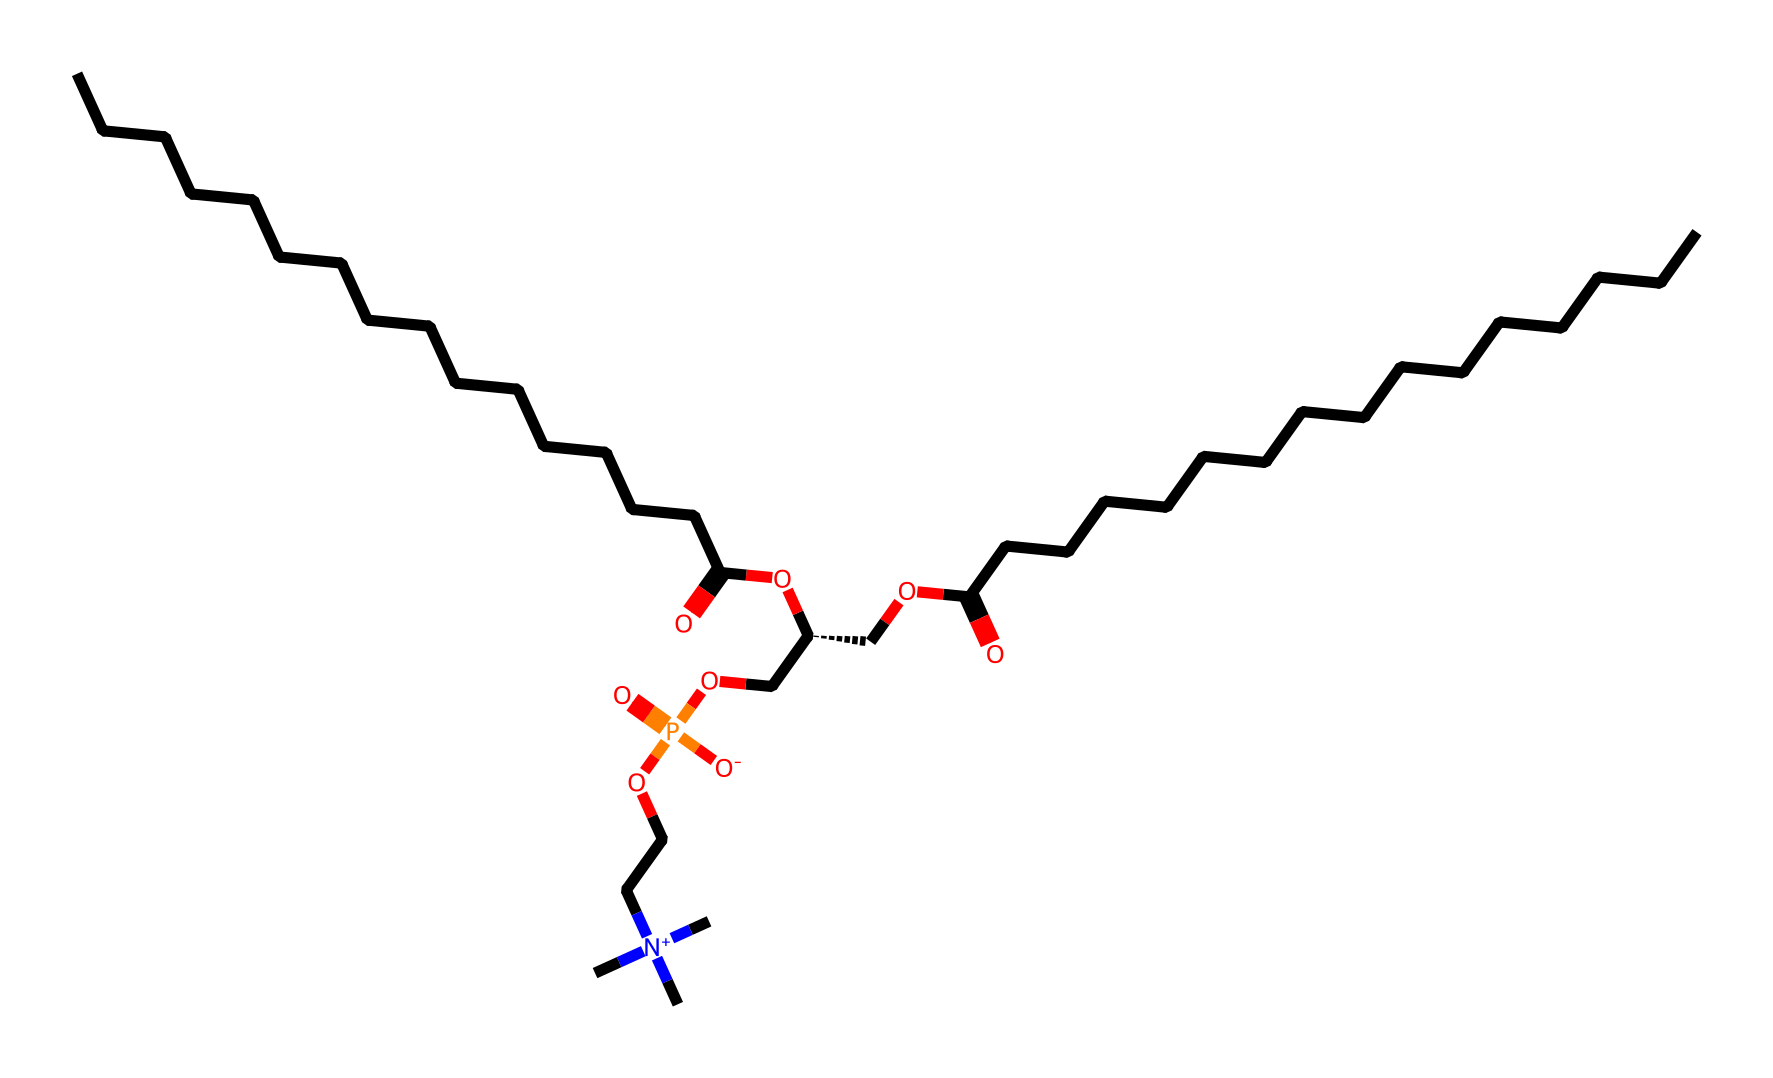What is the main functional group present in phosphatidylcholine? Phosphatidylcholine contains several functional groups, but the main one is the phosphate group, which is vital for its role in cellular membranes. The presence of oxygen and phosphorus atoms in a specific arrangement indicates the phosphate group.
Answer: phosphate How many carbon atoms are present in the chemical structure? By examining the SMILES representation, we can count the carbon atoms. There are a total of 26 carbon atoms indicated by the C symbols in the structure.
Answer: 26 What type of bonding is predominantly found in phosphatidylcholine? The primary type of bonding in phosphatidylcholine is covalent bonding, as all atoms in the structure are connected through shared electron pairs, typical for biological molecules.
Answer: covalent Which element in the structure is responsible for creating its charged nature? The charged nature comes from the presence of the nitrogen atom bonded to three methyl groups, creating a quaternary ammonium, which carries a positive charge.
Answer: nitrogen How many ester linkages are present in the structure of phosphatidylcholine? By examining the structure, we can identify two ester linkages, which form between the fatty acid components (the long carbon chains) and the glycerol backbone in the molecule.
Answer: 2 What role does the phosphate group play in cell membranes? The phosphate group contributes to the hydrophilic (water-attracting) head of the phosphatidylcholine molecule, allowing it to form bilayers in the aqueous environment of cell membranes.
Answer: hydrophilic 